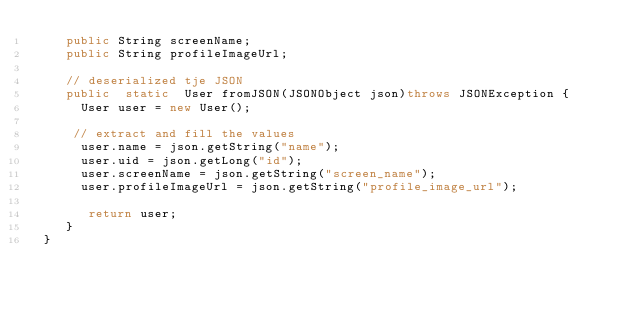Convert code to text. <code><loc_0><loc_0><loc_500><loc_500><_Java_>    public String screenName;
    public String profileImageUrl;

    // deserialized tje JSON
    public  static  User fromJSON(JSONObject json)throws JSONException {
      User user = new User();

     // extract and fill the values
      user.name = json.getString("name");
      user.uid = json.getLong("id");
      user.screenName = json.getString("screen_name");
      user.profileImageUrl = json.getString("profile_image_url");

       return user;
    }
 }</code> 